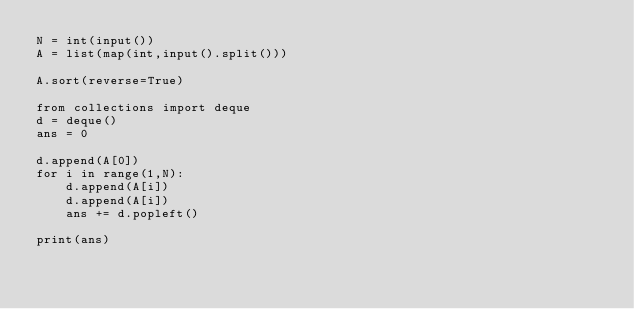<code> <loc_0><loc_0><loc_500><loc_500><_Python_>N = int(input())
A = list(map(int,input().split()))

A.sort(reverse=True)

from collections import deque
d = deque()
ans = 0

d.append(A[0])
for i in range(1,N):
    d.append(A[i])
    d.append(A[i])
    ans += d.popleft()

print(ans)</code> 